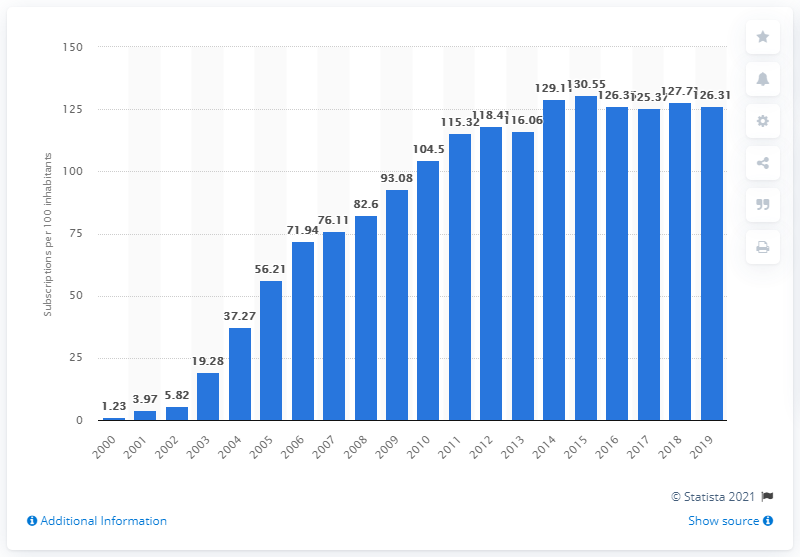Indicate a few pertinent items in this graphic. Between 2000 and 2019, there were an average of 126.31 mobile subscriptions registered for every 100 people in Tunisia. 